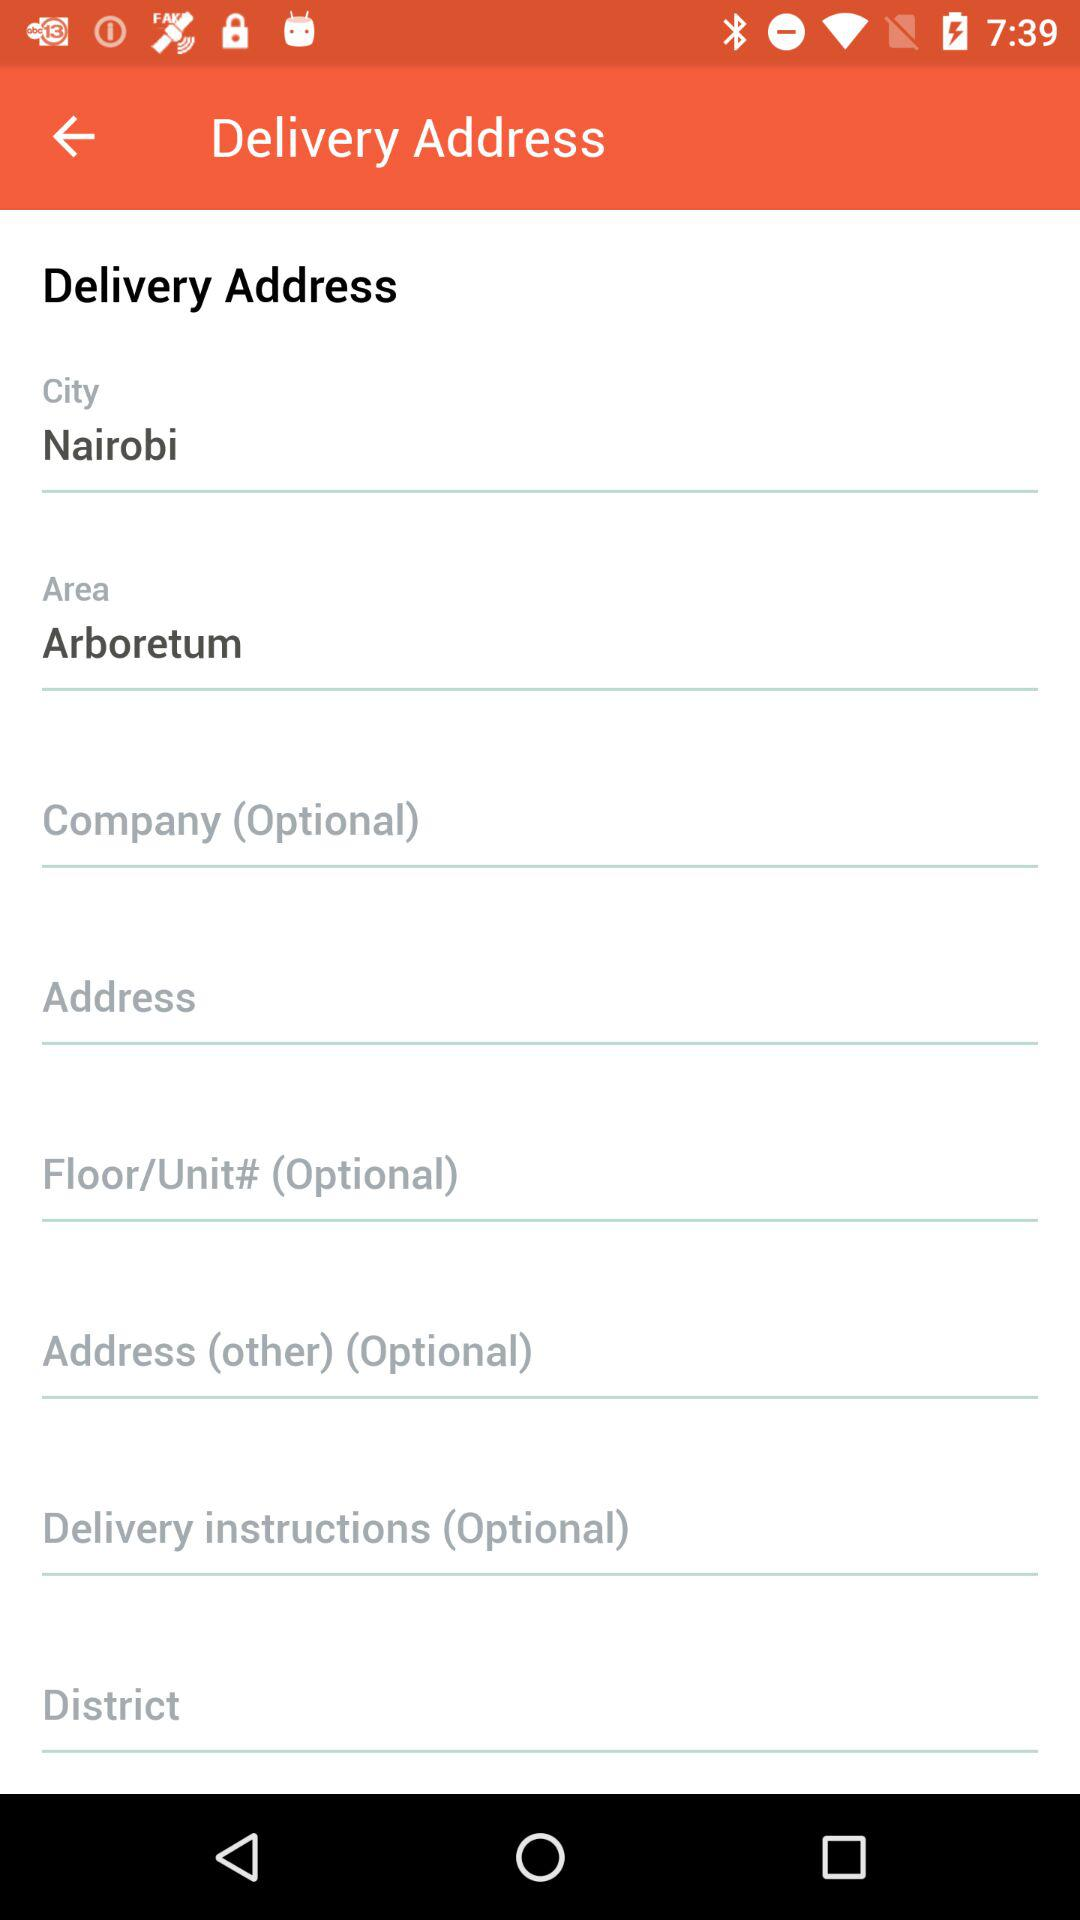What is the city name? The city name is Nairobi. 